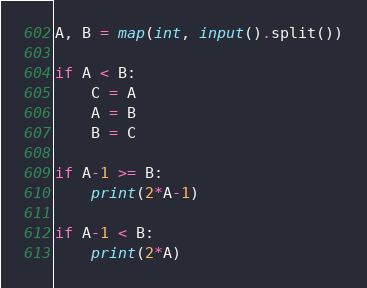Convert code to text. <code><loc_0><loc_0><loc_500><loc_500><_Python_>A, B = map(int, input().split())

if A < B:
    C = A
    A = B
    B = C

if A-1 >= B:
    print(2*A-1)

if A-1 < B:
    print(2*A)</code> 